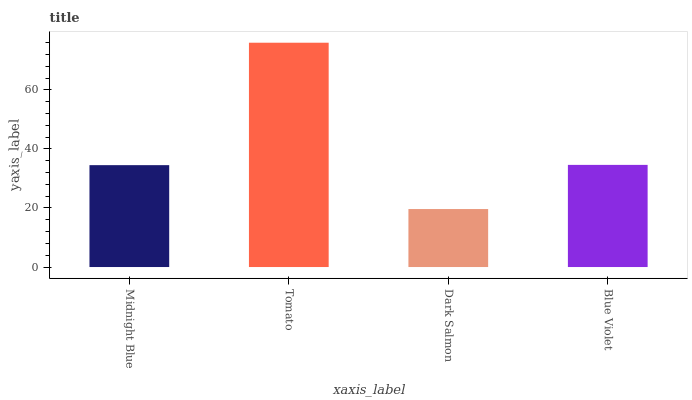Is Dark Salmon the minimum?
Answer yes or no. Yes. Is Tomato the maximum?
Answer yes or no. Yes. Is Tomato the minimum?
Answer yes or no. No. Is Dark Salmon the maximum?
Answer yes or no. No. Is Tomato greater than Dark Salmon?
Answer yes or no. Yes. Is Dark Salmon less than Tomato?
Answer yes or no. Yes. Is Dark Salmon greater than Tomato?
Answer yes or no. No. Is Tomato less than Dark Salmon?
Answer yes or no. No. Is Blue Violet the high median?
Answer yes or no. Yes. Is Midnight Blue the low median?
Answer yes or no. Yes. Is Midnight Blue the high median?
Answer yes or no. No. Is Tomato the low median?
Answer yes or no. No. 